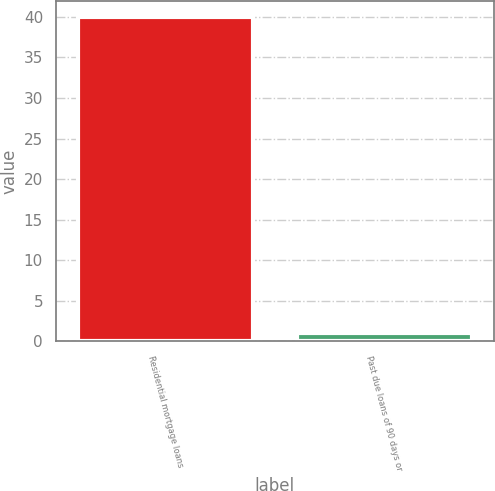<chart> <loc_0><loc_0><loc_500><loc_500><bar_chart><fcel>Residential mortgage loans<fcel>Past due loans of 90 days or<nl><fcel>40<fcel>1<nl></chart> 